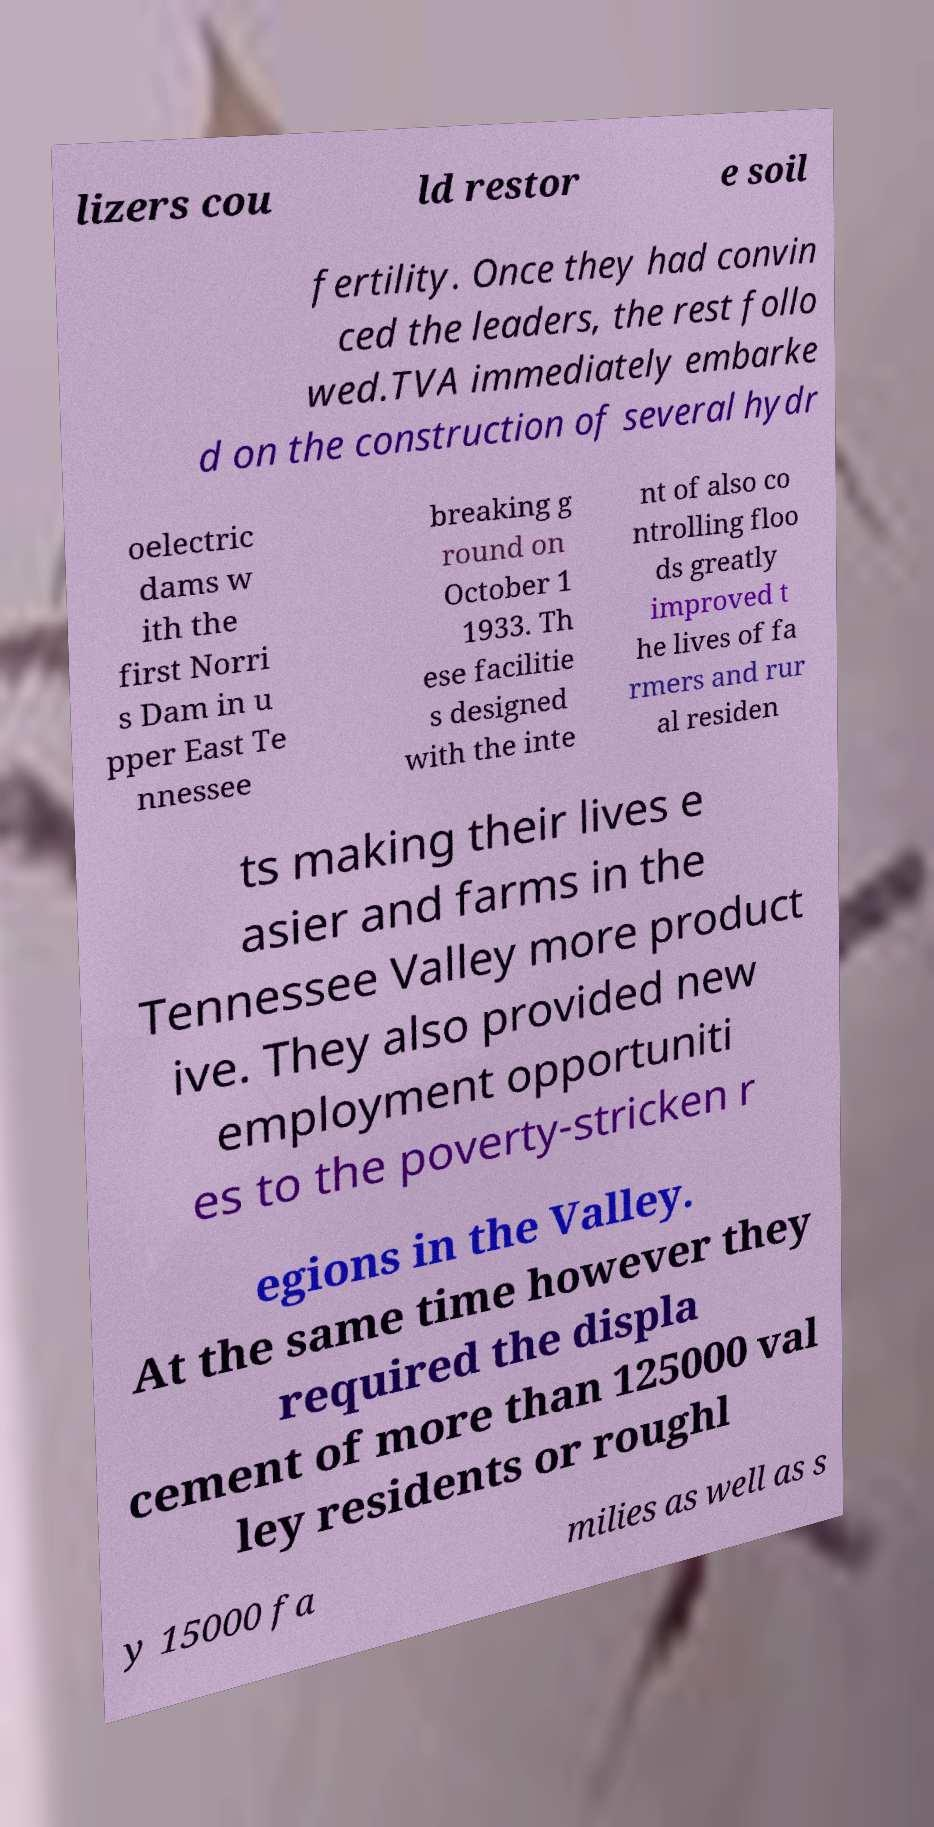For documentation purposes, I need the text within this image transcribed. Could you provide that? lizers cou ld restor e soil fertility. Once they had convin ced the leaders, the rest follo wed.TVA immediately embarke d on the construction of several hydr oelectric dams w ith the first Norri s Dam in u pper East Te nnessee breaking g round on October 1 1933. Th ese facilitie s designed with the inte nt of also co ntrolling floo ds greatly improved t he lives of fa rmers and rur al residen ts making their lives e asier and farms in the Tennessee Valley more product ive. They also provided new employment opportuniti es to the poverty-stricken r egions in the Valley. At the same time however they required the displa cement of more than 125000 val ley residents or roughl y 15000 fa milies as well as s 